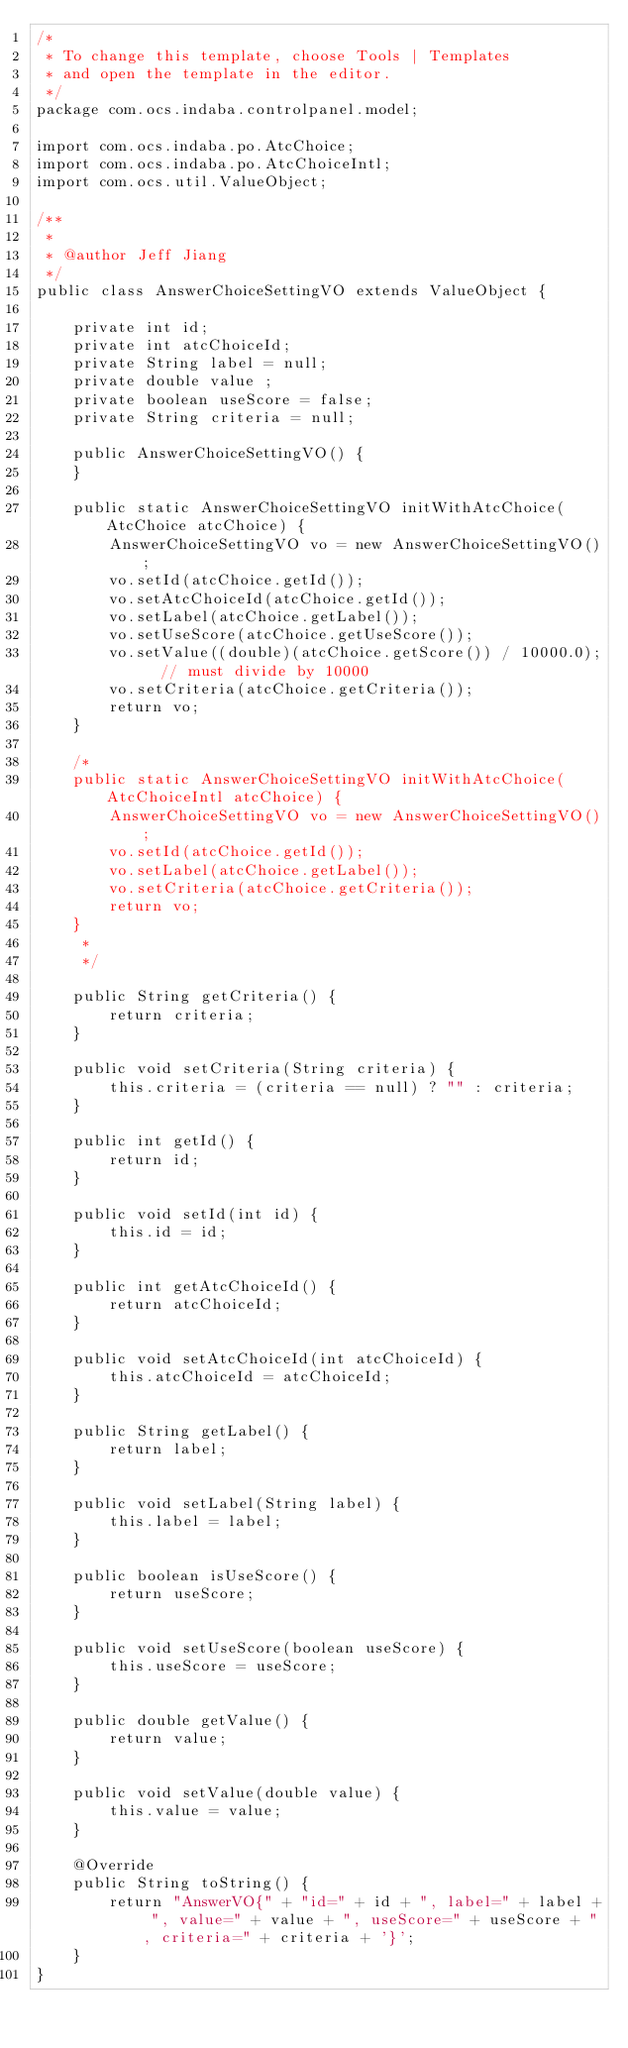<code> <loc_0><loc_0><loc_500><loc_500><_Java_>/*
 * To change this template, choose Tools | Templates
 * and open the template in the editor.
 */
package com.ocs.indaba.controlpanel.model;

import com.ocs.indaba.po.AtcChoice;
import com.ocs.indaba.po.AtcChoiceIntl;
import com.ocs.util.ValueObject;

/**
 *
 * @author Jeff Jiang
 */
public class AnswerChoiceSettingVO extends ValueObject {

    private int id;
    private int atcChoiceId;
    private String label = null;
    private double value ;
    private boolean useScore = false;
    private String criteria = null;

    public AnswerChoiceSettingVO() {
    }

    public static AnswerChoiceSettingVO initWithAtcChoice(AtcChoice atcChoice) {
        AnswerChoiceSettingVO vo = new AnswerChoiceSettingVO();
        vo.setId(atcChoice.getId());
        vo.setAtcChoiceId(atcChoice.getId());
        vo.setLabel(atcChoice.getLabel());
        vo.setUseScore(atcChoice.getUseScore());
        vo.setValue((double)(atcChoice.getScore()) / 10000.0);  // must divide by 10000
        vo.setCriteria(atcChoice.getCriteria());
        return vo;
    }

    /*
    public static AnswerChoiceSettingVO initWithAtcChoice(AtcChoiceIntl atcChoice) {
        AnswerChoiceSettingVO vo = new AnswerChoiceSettingVO();
        vo.setId(atcChoice.getId());
        vo.setLabel(atcChoice.getLabel());
        vo.setCriteria(atcChoice.getCriteria());
        return vo;
    }
     * 
     */

    public String getCriteria() {
        return criteria;
    }

    public void setCriteria(String criteria) {
        this.criteria = (criteria == null) ? "" : criteria;
    }

    public int getId() {
        return id;
    }

    public void setId(int id) {
        this.id = id;
    }

    public int getAtcChoiceId() {
        return atcChoiceId;
    }

    public void setAtcChoiceId(int atcChoiceId) {
        this.atcChoiceId = atcChoiceId;
    }

    public String getLabel() {
        return label;
    }

    public void setLabel(String label) {
        this.label = label;
    }

    public boolean isUseScore() {
        return useScore;
    }

    public void setUseScore(boolean useScore) {
        this.useScore = useScore;
    }

    public double getValue() {
        return value;
    }

    public void setValue(double value) {
        this.value = value;
    }

    @Override
    public String toString() {
        return "AnswerVO{" + "id=" + id + ", label=" + label + ", value=" + value + ", useScore=" + useScore + ", criteria=" + criteria + '}';
    }
}
</code> 